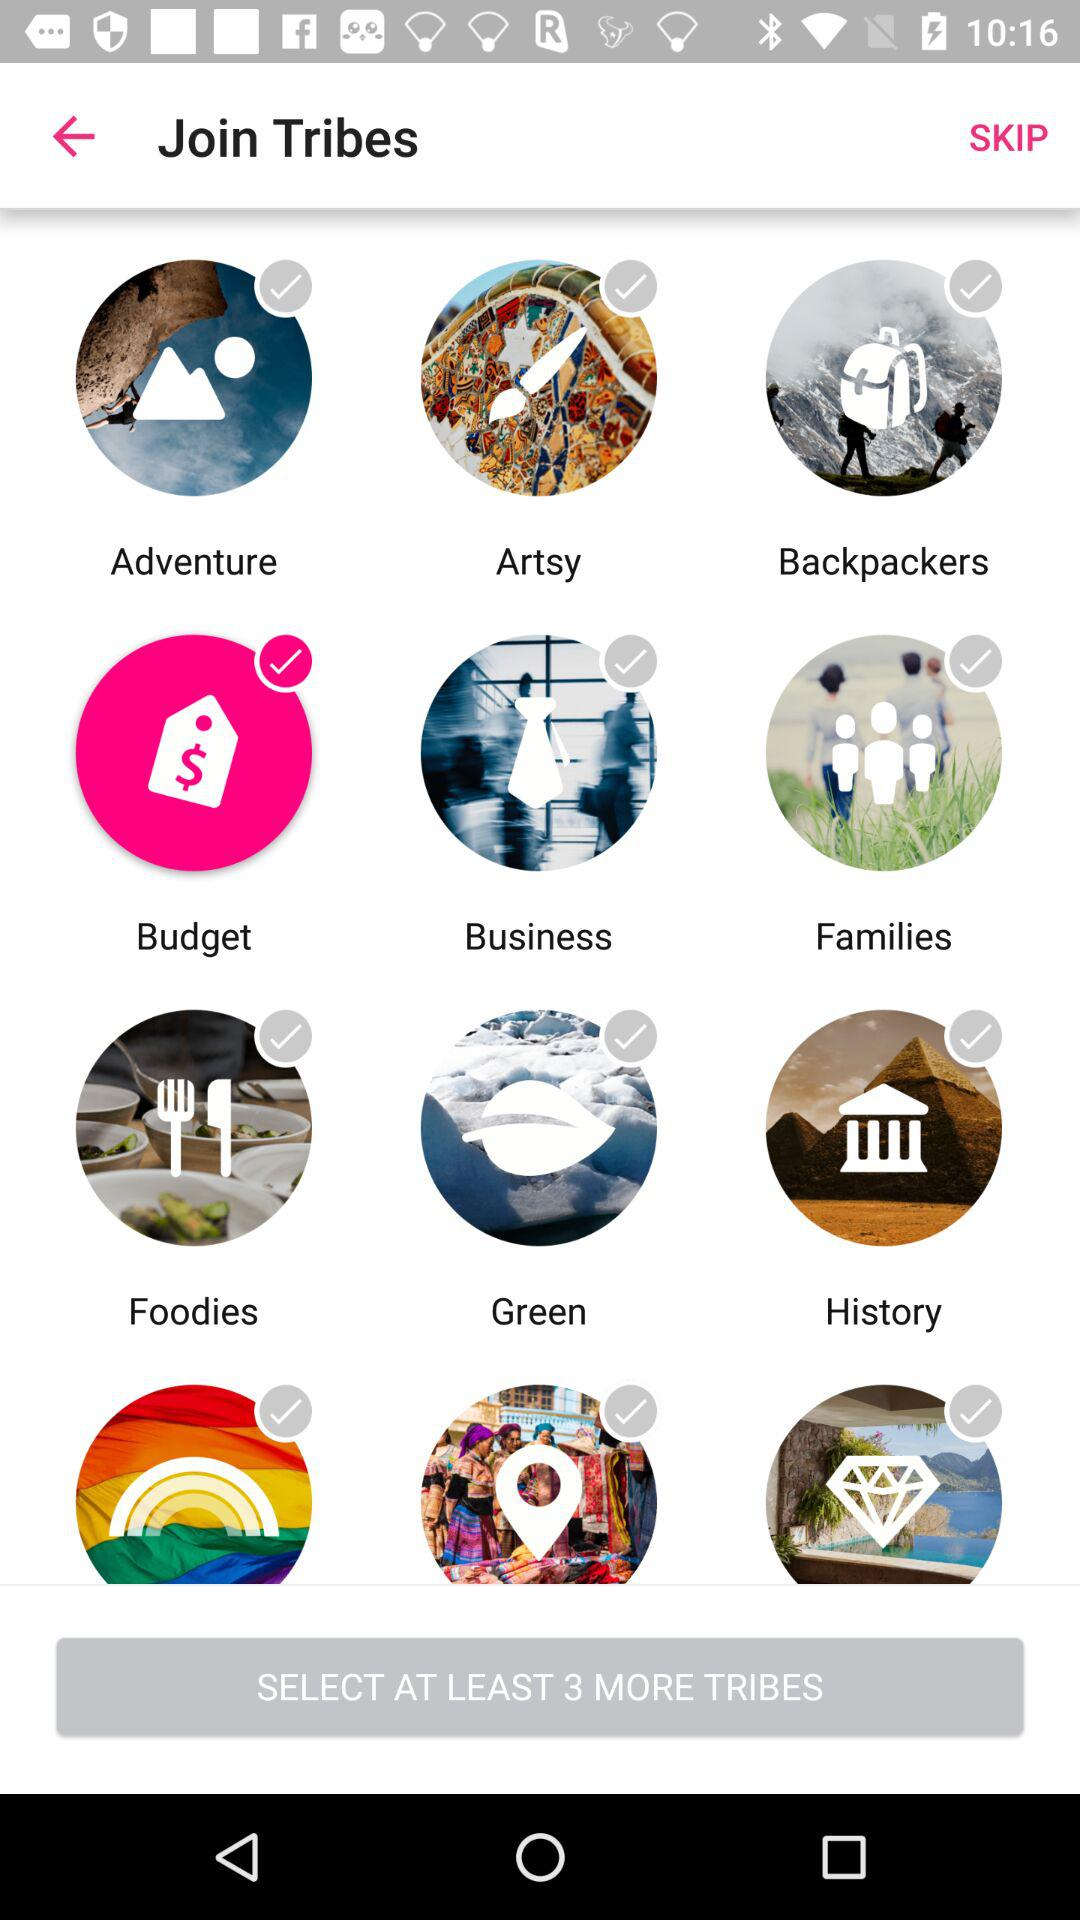How many tribes are in the first section?
Answer the question using a single word or phrase. 3 